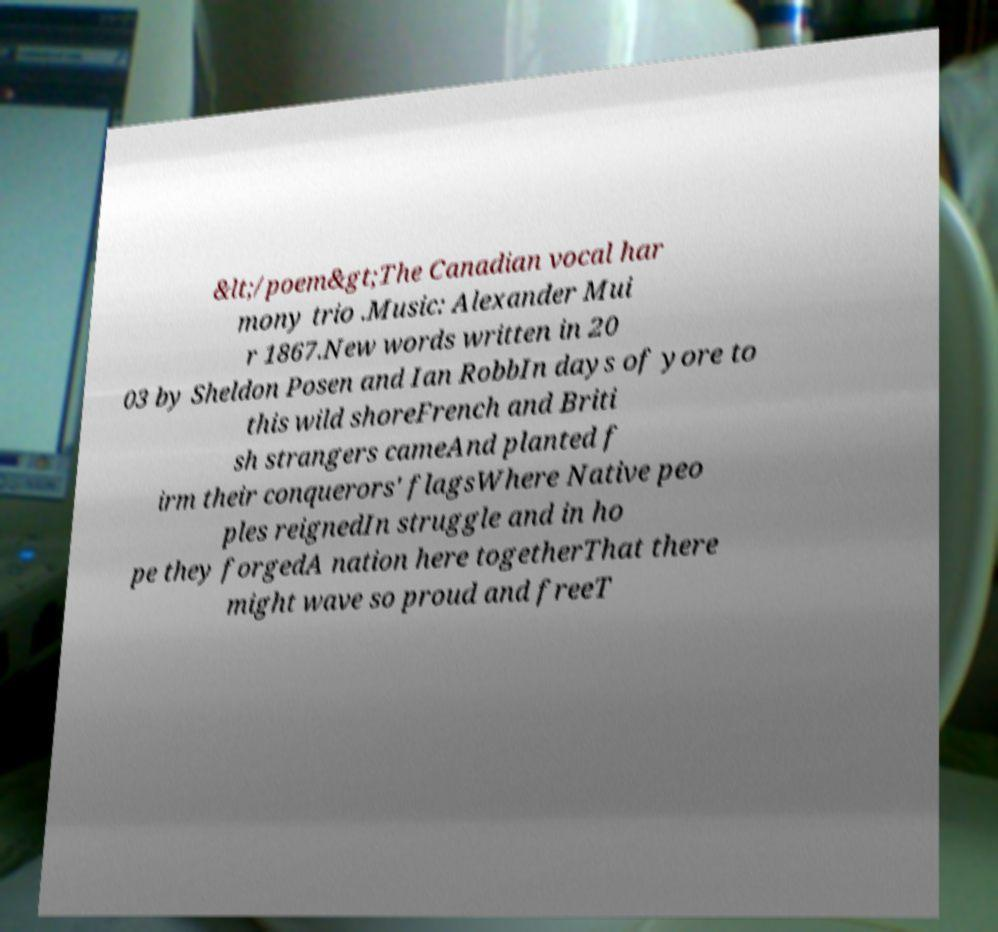Please identify and transcribe the text found in this image. &lt;/poem&gt;The Canadian vocal har mony trio .Music: Alexander Mui r 1867.New words written in 20 03 by Sheldon Posen and Ian RobbIn days of yore to this wild shoreFrench and Briti sh strangers cameAnd planted f irm their conquerors' flagsWhere Native peo ples reignedIn struggle and in ho pe they forgedA nation here togetherThat there might wave so proud and freeT 